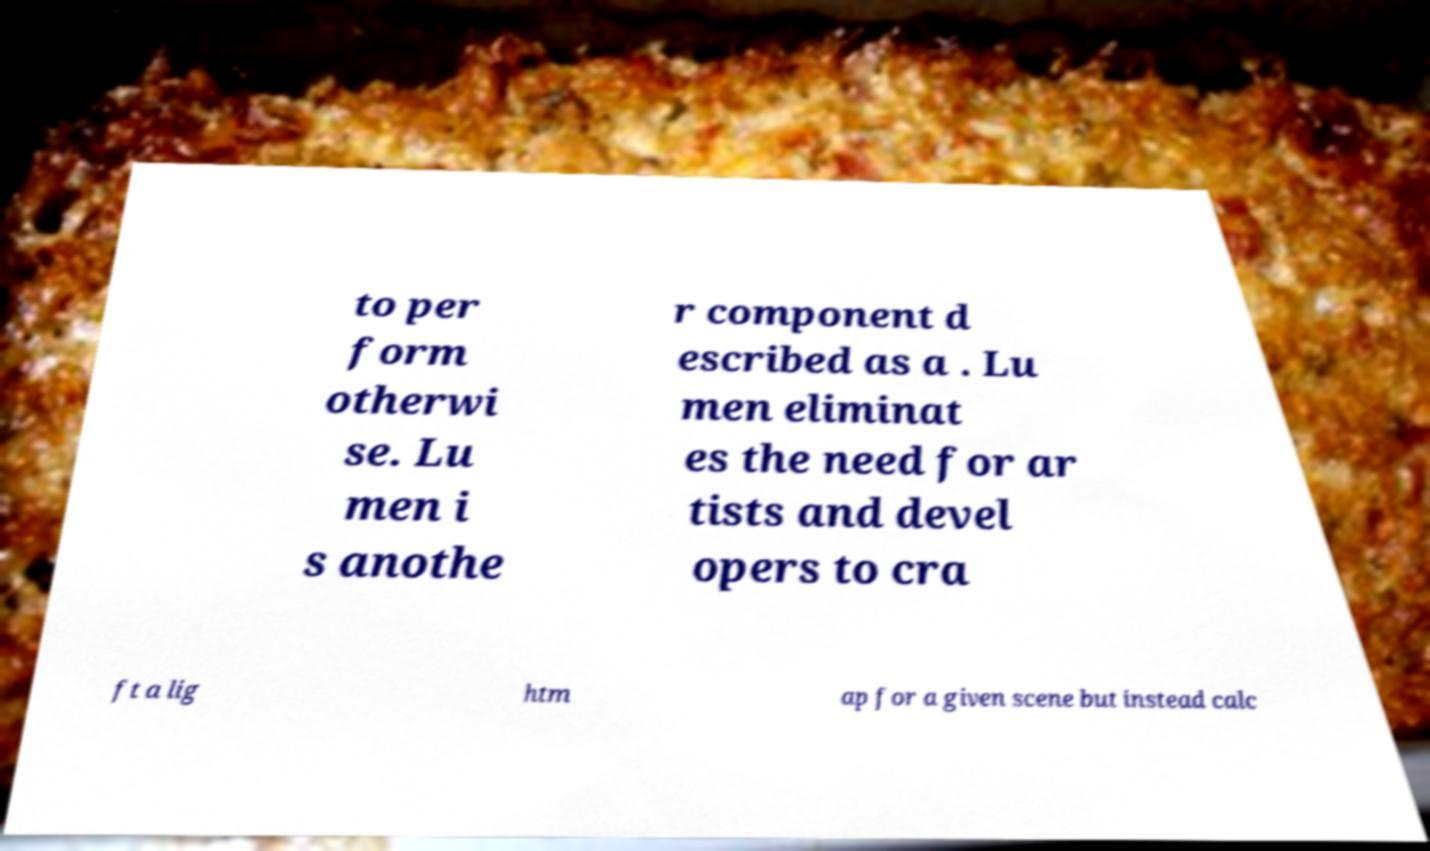Could you extract and type out the text from this image? to per form otherwi se. Lu men i s anothe r component d escribed as a . Lu men eliminat es the need for ar tists and devel opers to cra ft a lig htm ap for a given scene but instead calc 